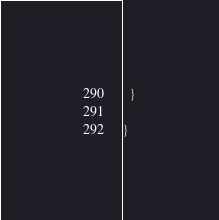<code> <loc_0><loc_0><loc_500><loc_500><_Java_>  }

}
</code> 